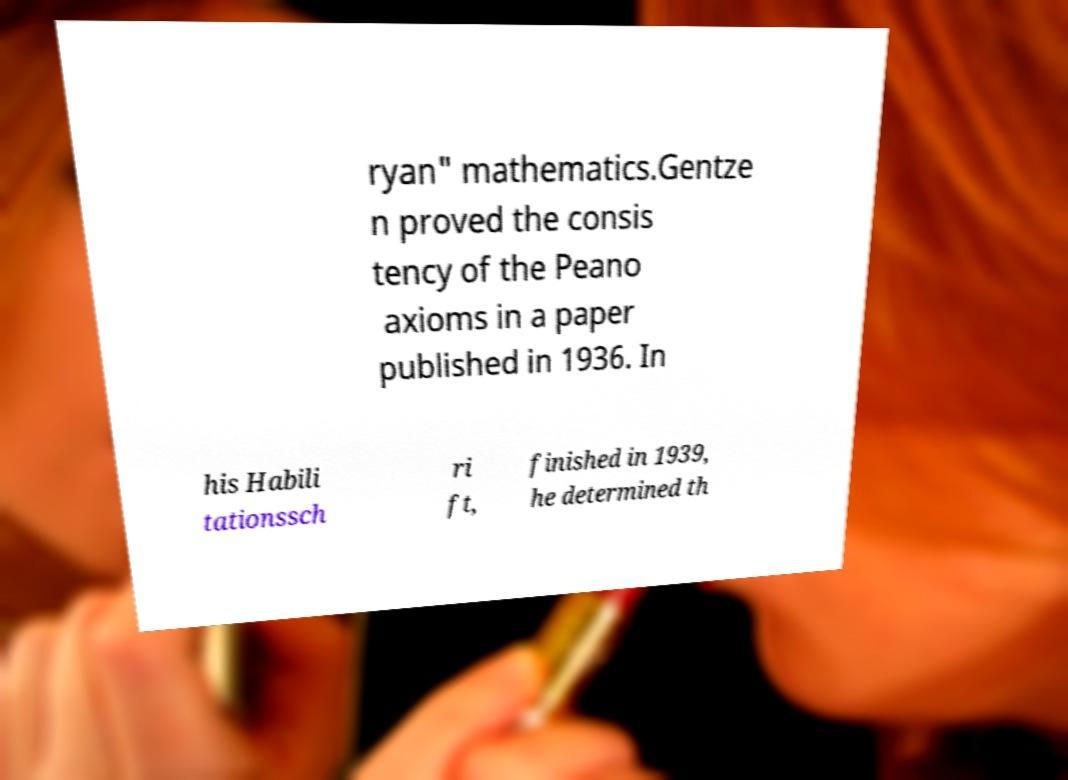Could you extract and type out the text from this image? ryan" mathematics.Gentze n proved the consis tency of the Peano axioms in a paper published in 1936. In his Habili tationssch ri ft, finished in 1939, he determined th 